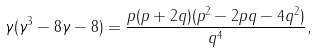<formula> <loc_0><loc_0><loc_500><loc_500>\gamma ( \gamma ^ { 3 } - 8 \gamma - 8 ) = \frac { p ( p + 2 q ) ( p ^ { 2 } - 2 p q - 4 q ^ { 2 } ) } { q ^ { 4 } } ,</formula> 